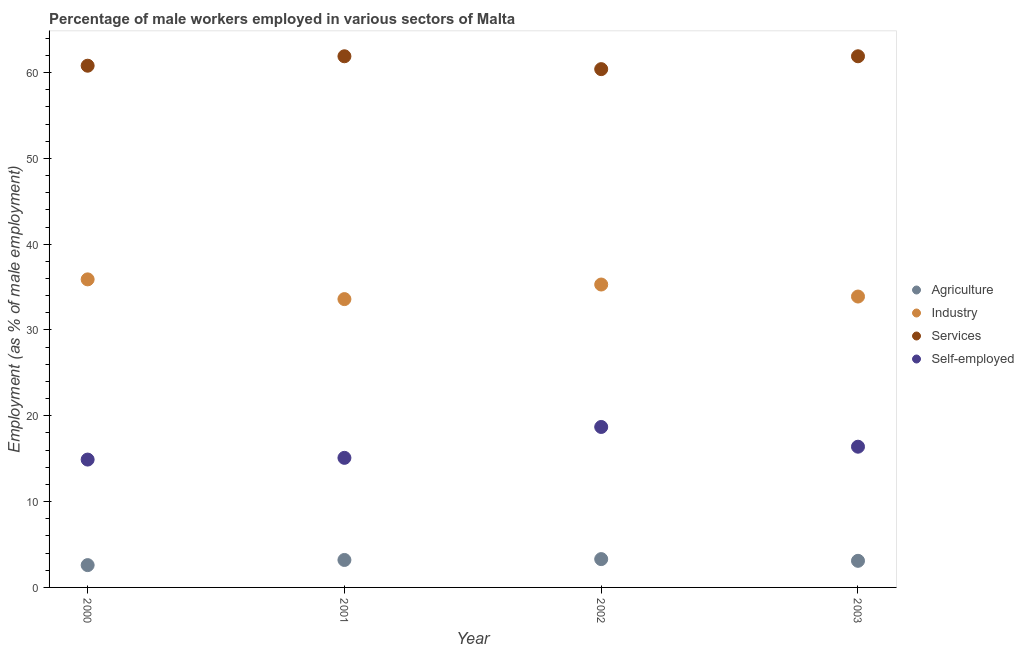Is the number of dotlines equal to the number of legend labels?
Offer a very short reply. Yes. What is the percentage of self employed male workers in 2002?
Your answer should be compact. 18.7. Across all years, what is the maximum percentage of male workers in services?
Provide a succinct answer. 61.9. Across all years, what is the minimum percentage of male workers in agriculture?
Your response must be concise. 2.6. What is the total percentage of self employed male workers in the graph?
Provide a short and direct response. 65.1. What is the difference between the percentage of male workers in agriculture in 2001 and that in 2003?
Provide a short and direct response. 0.1. What is the difference between the percentage of male workers in services in 2003 and the percentage of male workers in agriculture in 2001?
Give a very brief answer. 58.7. What is the average percentage of male workers in services per year?
Your response must be concise. 61.25. In the year 2000, what is the difference between the percentage of male workers in agriculture and percentage of male workers in industry?
Your response must be concise. -33.3. What is the ratio of the percentage of male workers in industry in 2002 to that in 2003?
Provide a succinct answer. 1.04. Is the percentage of male workers in services in 2002 less than that in 2003?
Your answer should be compact. Yes. What is the difference between the highest and the second highest percentage of male workers in agriculture?
Provide a succinct answer. 0.1. What is the difference between the highest and the lowest percentage of self employed male workers?
Provide a short and direct response. 3.8. In how many years, is the percentage of male workers in industry greater than the average percentage of male workers in industry taken over all years?
Ensure brevity in your answer.  2. Is it the case that in every year, the sum of the percentage of male workers in industry and percentage of male workers in agriculture is greater than the sum of percentage of self employed male workers and percentage of male workers in services?
Provide a succinct answer. No. Does the percentage of self employed male workers monotonically increase over the years?
Provide a succinct answer. No. How many dotlines are there?
Your response must be concise. 4. Are the values on the major ticks of Y-axis written in scientific E-notation?
Provide a succinct answer. No. Does the graph contain grids?
Your answer should be compact. No. Where does the legend appear in the graph?
Provide a succinct answer. Center right. How many legend labels are there?
Your answer should be very brief. 4. How are the legend labels stacked?
Provide a succinct answer. Vertical. What is the title of the graph?
Your answer should be compact. Percentage of male workers employed in various sectors of Malta. What is the label or title of the Y-axis?
Your answer should be compact. Employment (as % of male employment). What is the Employment (as % of male employment) of Agriculture in 2000?
Make the answer very short. 2.6. What is the Employment (as % of male employment) in Industry in 2000?
Provide a short and direct response. 35.9. What is the Employment (as % of male employment) of Services in 2000?
Offer a very short reply. 60.8. What is the Employment (as % of male employment) in Self-employed in 2000?
Offer a terse response. 14.9. What is the Employment (as % of male employment) of Agriculture in 2001?
Give a very brief answer. 3.2. What is the Employment (as % of male employment) of Industry in 2001?
Provide a short and direct response. 33.6. What is the Employment (as % of male employment) of Services in 2001?
Make the answer very short. 61.9. What is the Employment (as % of male employment) in Self-employed in 2001?
Your answer should be compact. 15.1. What is the Employment (as % of male employment) in Agriculture in 2002?
Provide a succinct answer. 3.3. What is the Employment (as % of male employment) of Industry in 2002?
Provide a succinct answer. 35.3. What is the Employment (as % of male employment) of Services in 2002?
Your answer should be very brief. 60.4. What is the Employment (as % of male employment) of Self-employed in 2002?
Your answer should be very brief. 18.7. What is the Employment (as % of male employment) in Agriculture in 2003?
Provide a succinct answer. 3.1. What is the Employment (as % of male employment) of Industry in 2003?
Ensure brevity in your answer.  33.9. What is the Employment (as % of male employment) in Services in 2003?
Keep it short and to the point. 61.9. What is the Employment (as % of male employment) in Self-employed in 2003?
Give a very brief answer. 16.4. Across all years, what is the maximum Employment (as % of male employment) in Agriculture?
Ensure brevity in your answer.  3.3. Across all years, what is the maximum Employment (as % of male employment) of Industry?
Your answer should be very brief. 35.9. Across all years, what is the maximum Employment (as % of male employment) of Services?
Ensure brevity in your answer.  61.9. Across all years, what is the maximum Employment (as % of male employment) in Self-employed?
Your response must be concise. 18.7. Across all years, what is the minimum Employment (as % of male employment) of Agriculture?
Your answer should be compact. 2.6. Across all years, what is the minimum Employment (as % of male employment) of Industry?
Offer a terse response. 33.6. Across all years, what is the minimum Employment (as % of male employment) of Services?
Give a very brief answer. 60.4. Across all years, what is the minimum Employment (as % of male employment) of Self-employed?
Give a very brief answer. 14.9. What is the total Employment (as % of male employment) in Agriculture in the graph?
Offer a terse response. 12.2. What is the total Employment (as % of male employment) in Industry in the graph?
Your response must be concise. 138.7. What is the total Employment (as % of male employment) in Services in the graph?
Offer a very short reply. 245. What is the total Employment (as % of male employment) in Self-employed in the graph?
Keep it short and to the point. 65.1. What is the difference between the Employment (as % of male employment) of Industry in 2000 and that in 2002?
Your answer should be compact. 0.6. What is the difference between the Employment (as % of male employment) in Services in 2000 and that in 2002?
Ensure brevity in your answer.  0.4. What is the difference between the Employment (as % of male employment) in Agriculture in 2000 and that in 2003?
Your answer should be compact. -0.5. What is the difference between the Employment (as % of male employment) in Industry in 2000 and that in 2003?
Offer a very short reply. 2. What is the difference between the Employment (as % of male employment) of Industry in 2001 and that in 2002?
Keep it short and to the point. -1.7. What is the difference between the Employment (as % of male employment) in Services in 2001 and that in 2003?
Your response must be concise. 0. What is the difference between the Employment (as % of male employment) in Agriculture in 2002 and that in 2003?
Your answer should be compact. 0.2. What is the difference between the Employment (as % of male employment) of Industry in 2002 and that in 2003?
Give a very brief answer. 1.4. What is the difference between the Employment (as % of male employment) in Services in 2002 and that in 2003?
Offer a very short reply. -1.5. What is the difference between the Employment (as % of male employment) of Self-employed in 2002 and that in 2003?
Ensure brevity in your answer.  2.3. What is the difference between the Employment (as % of male employment) of Agriculture in 2000 and the Employment (as % of male employment) of Industry in 2001?
Give a very brief answer. -31. What is the difference between the Employment (as % of male employment) in Agriculture in 2000 and the Employment (as % of male employment) in Services in 2001?
Make the answer very short. -59.3. What is the difference between the Employment (as % of male employment) in Industry in 2000 and the Employment (as % of male employment) in Self-employed in 2001?
Your answer should be compact. 20.8. What is the difference between the Employment (as % of male employment) in Services in 2000 and the Employment (as % of male employment) in Self-employed in 2001?
Keep it short and to the point. 45.7. What is the difference between the Employment (as % of male employment) of Agriculture in 2000 and the Employment (as % of male employment) of Industry in 2002?
Offer a terse response. -32.7. What is the difference between the Employment (as % of male employment) in Agriculture in 2000 and the Employment (as % of male employment) in Services in 2002?
Ensure brevity in your answer.  -57.8. What is the difference between the Employment (as % of male employment) of Agriculture in 2000 and the Employment (as % of male employment) of Self-employed in 2002?
Your answer should be very brief. -16.1. What is the difference between the Employment (as % of male employment) of Industry in 2000 and the Employment (as % of male employment) of Services in 2002?
Your answer should be compact. -24.5. What is the difference between the Employment (as % of male employment) in Industry in 2000 and the Employment (as % of male employment) in Self-employed in 2002?
Give a very brief answer. 17.2. What is the difference between the Employment (as % of male employment) of Services in 2000 and the Employment (as % of male employment) of Self-employed in 2002?
Make the answer very short. 42.1. What is the difference between the Employment (as % of male employment) in Agriculture in 2000 and the Employment (as % of male employment) in Industry in 2003?
Your answer should be very brief. -31.3. What is the difference between the Employment (as % of male employment) in Agriculture in 2000 and the Employment (as % of male employment) in Services in 2003?
Provide a short and direct response. -59.3. What is the difference between the Employment (as % of male employment) in Industry in 2000 and the Employment (as % of male employment) in Self-employed in 2003?
Make the answer very short. 19.5. What is the difference between the Employment (as % of male employment) of Services in 2000 and the Employment (as % of male employment) of Self-employed in 2003?
Your answer should be very brief. 44.4. What is the difference between the Employment (as % of male employment) in Agriculture in 2001 and the Employment (as % of male employment) in Industry in 2002?
Offer a terse response. -32.1. What is the difference between the Employment (as % of male employment) of Agriculture in 2001 and the Employment (as % of male employment) of Services in 2002?
Keep it short and to the point. -57.2. What is the difference between the Employment (as % of male employment) of Agriculture in 2001 and the Employment (as % of male employment) of Self-employed in 2002?
Make the answer very short. -15.5. What is the difference between the Employment (as % of male employment) of Industry in 2001 and the Employment (as % of male employment) of Services in 2002?
Your answer should be compact. -26.8. What is the difference between the Employment (as % of male employment) of Services in 2001 and the Employment (as % of male employment) of Self-employed in 2002?
Make the answer very short. 43.2. What is the difference between the Employment (as % of male employment) in Agriculture in 2001 and the Employment (as % of male employment) in Industry in 2003?
Keep it short and to the point. -30.7. What is the difference between the Employment (as % of male employment) in Agriculture in 2001 and the Employment (as % of male employment) in Services in 2003?
Make the answer very short. -58.7. What is the difference between the Employment (as % of male employment) of Agriculture in 2001 and the Employment (as % of male employment) of Self-employed in 2003?
Keep it short and to the point. -13.2. What is the difference between the Employment (as % of male employment) of Industry in 2001 and the Employment (as % of male employment) of Services in 2003?
Offer a very short reply. -28.3. What is the difference between the Employment (as % of male employment) of Services in 2001 and the Employment (as % of male employment) of Self-employed in 2003?
Offer a very short reply. 45.5. What is the difference between the Employment (as % of male employment) of Agriculture in 2002 and the Employment (as % of male employment) of Industry in 2003?
Your answer should be very brief. -30.6. What is the difference between the Employment (as % of male employment) of Agriculture in 2002 and the Employment (as % of male employment) of Services in 2003?
Make the answer very short. -58.6. What is the difference between the Employment (as % of male employment) of Industry in 2002 and the Employment (as % of male employment) of Services in 2003?
Your response must be concise. -26.6. What is the difference between the Employment (as % of male employment) of Industry in 2002 and the Employment (as % of male employment) of Self-employed in 2003?
Keep it short and to the point. 18.9. What is the difference between the Employment (as % of male employment) of Services in 2002 and the Employment (as % of male employment) of Self-employed in 2003?
Provide a short and direct response. 44. What is the average Employment (as % of male employment) of Agriculture per year?
Offer a terse response. 3.05. What is the average Employment (as % of male employment) in Industry per year?
Offer a terse response. 34.67. What is the average Employment (as % of male employment) of Services per year?
Give a very brief answer. 61.25. What is the average Employment (as % of male employment) in Self-employed per year?
Your answer should be compact. 16.27. In the year 2000, what is the difference between the Employment (as % of male employment) in Agriculture and Employment (as % of male employment) in Industry?
Offer a very short reply. -33.3. In the year 2000, what is the difference between the Employment (as % of male employment) of Agriculture and Employment (as % of male employment) of Services?
Keep it short and to the point. -58.2. In the year 2000, what is the difference between the Employment (as % of male employment) in Industry and Employment (as % of male employment) in Services?
Ensure brevity in your answer.  -24.9. In the year 2000, what is the difference between the Employment (as % of male employment) in Industry and Employment (as % of male employment) in Self-employed?
Your answer should be compact. 21. In the year 2000, what is the difference between the Employment (as % of male employment) of Services and Employment (as % of male employment) of Self-employed?
Your answer should be very brief. 45.9. In the year 2001, what is the difference between the Employment (as % of male employment) in Agriculture and Employment (as % of male employment) in Industry?
Offer a terse response. -30.4. In the year 2001, what is the difference between the Employment (as % of male employment) of Agriculture and Employment (as % of male employment) of Services?
Make the answer very short. -58.7. In the year 2001, what is the difference between the Employment (as % of male employment) of Industry and Employment (as % of male employment) of Services?
Provide a short and direct response. -28.3. In the year 2001, what is the difference between the Employment (as % of male employment) in Industry and Employment (as % of male employment) in Self-employed?
Give a very brief answer. 18.5. In the year 2001, what is the difference between the Employment (as % of male employment) in Services and Employment (as % of male employment) in Self-employed?
Your answer should be compact. 46.8. In the year 2002, what is the difference between the Employment (as % of male employment) in Agriculture and Employment (as % of male employment) in Industry?
Provide a succinct answer. -32. In the year 2002, what is the difference between the Employment (as % of male employment) of Agriculture and Employment (as % of male employment) of Services?
Keep it short and to the point. -57.1. In the year 2002, what is the difference between the Employment (as % of male employment) of Agriculture and Employment (as % of male employment) of Self-employed?
Offer a very short reply. -15.4. In the year 2002, what is the difference between the Employment (as % of male employment) in Industry and Employment (as % of male employment) in Services?
Offer a very short reply. -25.1. In the year 2002, what is the difference between the Employment (as % of male employment) in Services and Employment (as % of male employment) in Self-employed?
Keep it short and to the point. 41.7. In the year 2003, what is the difference between the Employment (as % of male employment) in Agriculture and Employment (as % of male employment) in Industry?
Ensure brevity in your answer.  -30.8. In the year 2003, what is the difference between the Employment (as % of male employment) of Agriculture and Employment (as % of male employment) of Services?
Give a very brief answer. -58.8. In the year 2003, what is the difference between the Employment (as % of male employment) in Services and Employment (as % of male employment) in Self-employed?
Your answer should be compact. 45.5. What is the ratio of the Employment (as % of male employment) in Agriculture in 2000 to that in 2001?
Your response must be concise. 0.81. What is the ratio of the Employment (as % of male employment) of Industry in 2000 to that in 2001?
Provide a short and direct response. 1.07. What is the ratio of the Employment (as % of male employment) of Services in 2000 to that in 2001?
Your answer should be very brief. 0.98. What is the ratio of the Employment (as % of male employment) of Agriculture in 2000 to that in 2002?
Provide a short and direct response. 0.79. What is the ratio of the Employment (as % of male employment) of Industry in 2000 to that in 2002?
Provide a succinct answer. 1.02. What is the ratio of the Employment (as % of male employment) of Services in 2000 to that in 2002?
Provide a short and direct response. 1.01. What is the ratio of the Employment (as % of male employment) of Self-employed in 2000 to that in 2002?
Make the answer very short. 0.8. What is the ratio of the Employment (as % of male employment) of Agriculture in 2000 to that in 2003?
Offer a very short reply. 0.84. What is the ratio of the Employment (as % of male employment) in Industry in 2000 to that in 2003?
Provide a succinct answer. 1.06. What is the ratio of the Employment (as % of male employment) in Services in 2000 to that in 2003?
Your answer should be compact. 0.98. What is the ratio of the Employment (as % of male employment) in Self-employed in 2000 to that in 2003?
Make the answer very short. 0.91. What is the ratio of the Employment (as % of male employment) of Agriculture in 2001 to that in 2002?
Your answer should be compact. 0.97. What is the ratio of the Employment (as % of male employment) in Industry in 2001 to that in 2002?
Make the answer very short. 0.95. What is the ratio of the Employment (as % of male employment) in Services in 2001 to that in 2002?
Provide a short and direct response. 1.02. What is the ratio of the Employment (as % of male employment) of Self-employed in 2001 to that in 2002?
Your response must be concise. 0.81. What is the ratio of the Employment (as % of male employment) in Agriculture in 2001 to that in 2003?
Make the answer very short. 1.03. What is the ratio of the Employment (as % of male employment) in Self-employed in 2001 to that in 2003?
Keep it short and to the point. 0.92. What is the ratio of the Employment (as % of male employment) in Agriculture in 2002 to that in 2003?
Offer a very short reply. 1.06. What is the ratio of the Employment (as % of male employment) of Industry in 2002 to that in 2003?
Give a very brief answer. 1.04. What is the ratio of the Employment (as % of male employment) in Services in 2002 to that in 2003?
Your answer should be very brief. 0.98. What is the ratio of the Employment (as % of male employment) of Self-employed in 2002 to that in 2003?
Offer a very short reply. 1.14. What is the difference between the highest and the second highest Employment (as % of male employment) of Agriculture?
Your answer should be compact. 0.1. What is the difference between the highest and the lowest Employment (as % of male employment) of Industry?
Your response must be concise. 2.3. What is the difference between the highest and the lowest Employment (as % of male employment) of Services?
Your response must be concise. 1.5. 